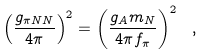Convert formula to latex. <formula><loc_0><loc_0><loc_500><loc_500>\left ( \frac { g _ { \pi N N } } { 4 \pi } \right ) ^ { 2 } = \left ( \frac { g _ { A } m _ { N } } { 4 \pi f _ { \pi } } \right ) ^ { 2 } \ ,</formula> 